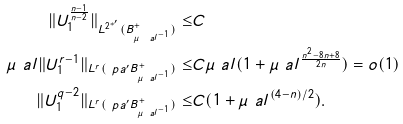Convert formula to latex. <formula><loc_0><loc_0><loc_500><loc_500>\| U _ { 1 } ^ { \frac { n - 1 } { n - 2 } } \| _ { L ^ { 2 ^ { * ^ { \prime } } } ( B ^ { + } _ { \mu _ { \ } a l ^ { - 1 } } ) } \leq & C \\ \mu _ { \ } a l \| U _ { 1 } ^ { r - 1 } \| _ { L ^ { r } ( \ p a ^ { \prime } B ^ { + } _ { \mu _ { \ } a l ^ { - 1 } } ) } \leq & C \mu _ { \ } a l ( 1 + \mu _ { \ } a l ^ { \frac { n ^ { 2 } - 8 n + 8 } { 2 n } } ) = o ( 1 ) \\ \| U ^ { q - 2 } _ { 1 } \| _ { L ^ { r } ( \ p a ^ { \prime } B ^ { + } _ { \mu _ { \ } a l ^ { - 1 } } ) } \leq & C ( 1 + \mu _ { \ } a l ^ { ( 4 - n ) / 2 } ) .</formula> 